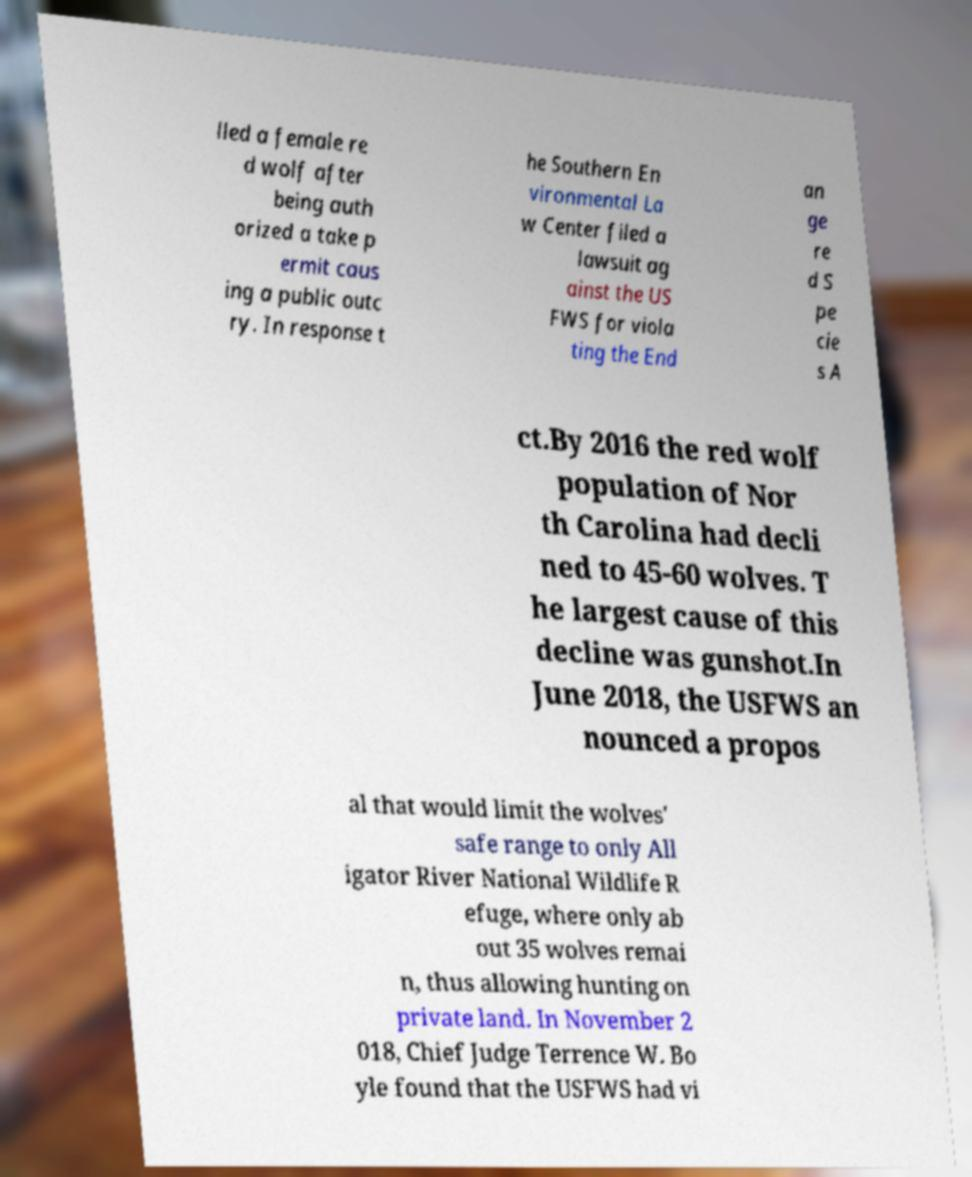Can you read and provide the text displayed in the image?This photo seems to have some interesting text. Can you extract and type it out for me? lled a female re d wolf after being auth orized a take p ermit caus ing a public outc ry. In response t he Southern En vironmental La w Center filed a lawsuit ag ainst the US FWS for viola ting the End an ge re d S pe cie s A ct.By 2016 the red wolf population of Nor th Carolina had decli ned to 45-60 wolves. T he largest cause of this decline was gunshot.In June 2018, the USFWS an nounced a propos al that would limit the wolves' safe range to only All igator River National Wildlife R efuge, where only ab out 35 wolves remai n, thus allowing hunting on private land. In November 2 018, Chief Judge Terrence W. Bo yle found that the USFWS had vi 